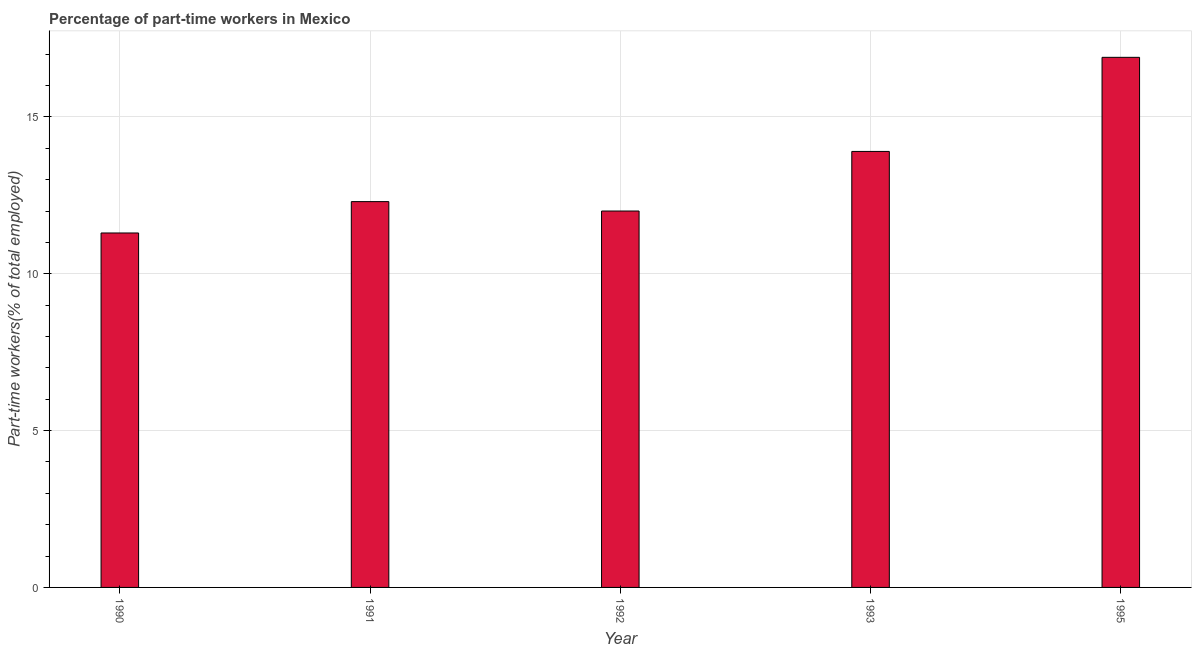Does the graph contain any zero values?
Offer a very short reply. No. What is the title of the graph?
Make the answer very short. Percentage of part-time workers in Mexico. What is the label or title of the X-axis?
Your answer should be very brief. Year. What is the label or title of the Y-axis?
Make the answer very short. Part-time workers(% of total employed). What is the percentage of part-time workers in 1991?
Make the answer very short. 12.3. Across all years, what is the maximum percentage of part-time workers?
Keep it short and to the point. 16.9. Across all years, what is the minimum percentage of part-time workers?
Offer a very short reply. 11.3. In which year was the percentage of part-time workers maximum?
Your answer should be compact. 1995. What is the sum of the percentage of part-time workers?
Offer a very short reply. 66.4. What is the difference between the percentage of part-time workers in 1991 and 1995?
Provide a short and direct response. -4.6. What is the average percentage of part-time workers per year?
Provide a succinct answer. 13.28. What is the median percentage of part-time workers?
Give a very brief answer. 12.3. Do a majority of the years between 1992 and 1995 (inclusive) have percentage of part-time workers greater than 15 %?
Offer a very short reply. No. What is the ratio of the percentage of part-time workers in 1992 to that in 1993?
Your response must be concise. 0.86. Is the difference between the percentage of part-time workers in 1991 and 1995 greater than the difference between any two years?
Provide a succinct answer. No. What is the difference between the highest and the second highest percentage of part-time workers?
Offer a very short reply. 3. What is the difference between the highest and the lowest percentage of part-time workers?
Make the answer very short. 5.6. How many bars are there?
Offer a terse response. 5. Are the values on the major ticks of Y-axis written in scientific E-notation?
Your response must be concise. No. What is the Part-time workers(% of total employed) of 1990?
Offer a very short reply. 11.3. What is the Part-time workers(% of total employed) in 1991?
Your answer should be compact. 12.3. What is the Part-time workers(% of total employed) of 1993?
Give a very brief answer. 13.9. What is the Part-time workers(% of total employed) in 1995?
Make the answer very short. 16.9. What is the difference between the Part-time workers(% of total employed) in 1990 and 1991?
Offer a very short reply. -1. What is the difference between the Part-time workers(% of total employed) in 1990 and 1992?
Ensure brevity in your answer.  -0.7. What is the difference between the Part-time workers(% of total employed) in 1990 and 1993?
Your response must be concise. -2.6. What is the difference between the Part-time workers(% of total employed) in 1990 and 1995?
Offer a terse response. -5.6. What is the difference between the Part-time workers(% of total employed) in 1991 and 1992?
Ensure brevity in your answer.  0.3. What is the difference between the Part-time workers(% of total employed) in 1991 and 1993?
Your response must be concise. -1.6. What is the ratio of the Part-time workers(% of total employed) in 1990 to that in 1991?
Provide a short and direct response. 0.92. What is the ratio of the Part-time workers(% of total employed) in 1990 to that in 1992?
Your answer should be very brief. 0.94. What is the ratio of the Part-time workers(% of total employed) in 1990 to that in 1993?
Offer a terse response. 0.81. What is the ratio of the Part-time workers(% of total employed) in 1990 to that in 1995?
Offer a very short reply. 0.67. What is the ratio of the Part-time workers(% of total employed) in 1991 to that in 1993?
Offer a very short reply. 0.89. What is the ratio of the Part-time workers(% of total employed) in 1991 to that in 1995?
Your answer should be very brief. 0.73. What is the ratio of the Part-time workers(% of total employed) in 1992 to that in 1993?
Give a very brief answer. 0.86. What is the ratio of the Part-time workers(% of total employed) in 1992 to that in 1995?
Your response must be concise. 0.71. What is the ratio of the Part-time workers(% of total employed) in 1993 to that in 1995?
Your answer should be very brief. 0.82. 